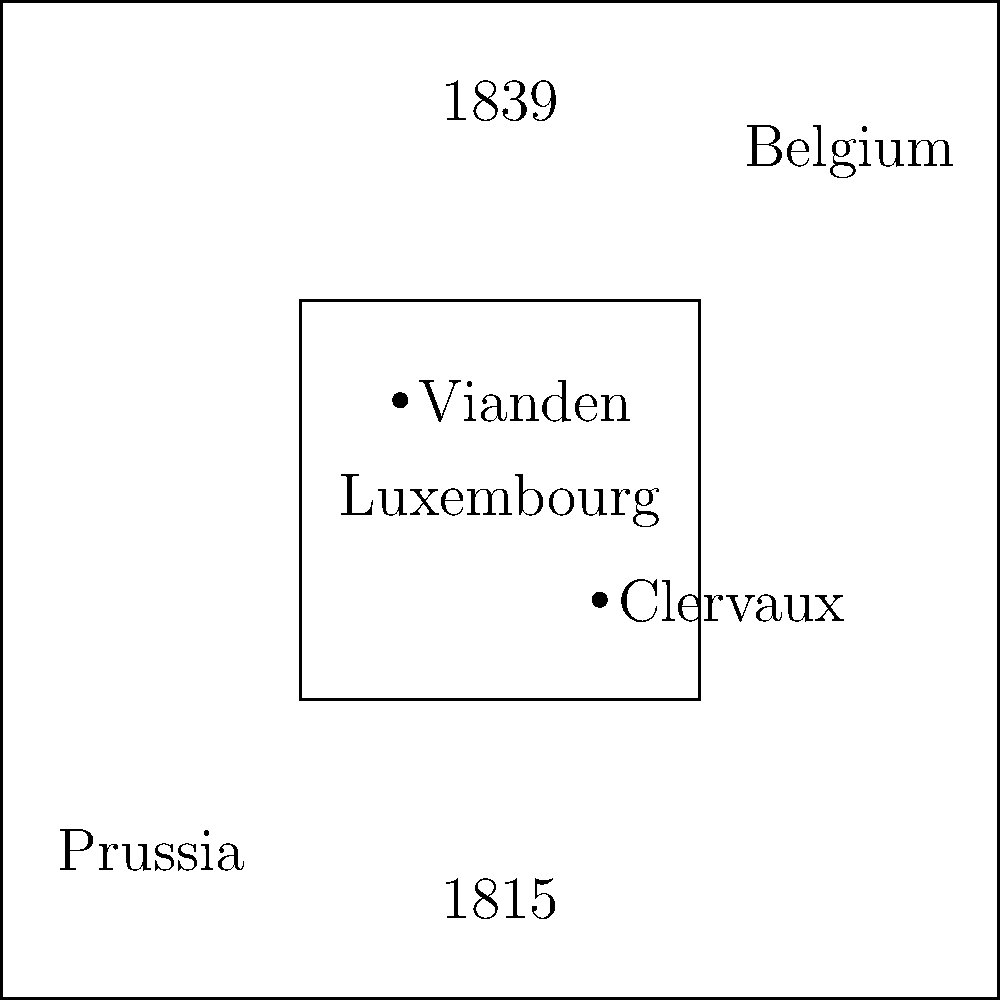Based on the historical map showing territorial changes in Luxembourg, which noble estate appears to have remained within Luxembourg's borders after the 1839 partition, potentially preserving its lineage within the country? To answer this question, we need to analyze the map and follow these steps:

1. Identify the timeframes: The map shows Luxembourg's territory in 1815 and 1839.

2. Observe the territorial changes: The map indicates that Luxembourg lost significant territory between 1815 and 1839, with portions going to Belgium and Prussia.

3. Locate the noble estates: Two estates are marked on the map - Vianden and Clervaux.

4. Analyze their positions:
   a. Vianden is located in the northern part of the 1839 Luxembourg territory.
   b. Clervaux is positioned in the central part of the 1839 Luxembourg territory.

5. Consider the question: We need to determine which estate remained within Luxembourg's borders after the 1839 partition.

6. Compare the estates' locations with the 1839 borders:
   a. Vianden is clearly within the 1839 Luxembourg borders.
   b. Clervaux is also within the 1839 Luxembourg borders.

7. Conclusion: Both Vianden and Clervaux appear to have remained within Luxembourg's borders after the 1839 partition. However, Clervaux is more centrally located and less likely to have been affected by border changes.

Therefore, while both estates could have preserved their lineage within Luxembourg, Clervaux appears to be the safer answer based on its more central location.
Answer: Clervaux 